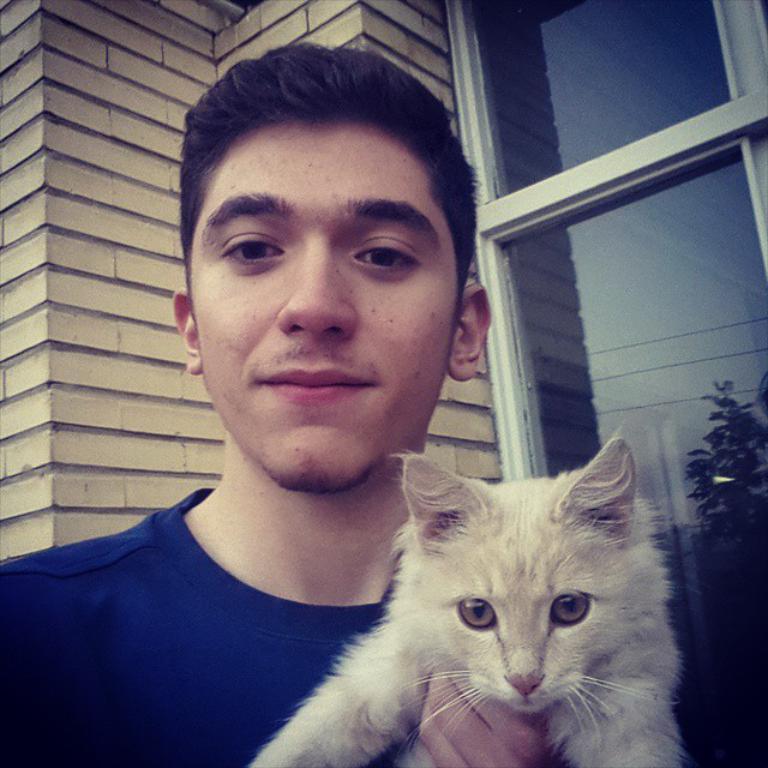Could you give a brief overview of what you see in this image? In the middle of the image a man is standing and holding a cat. Behind him there is a wall. Top right side of the image there is a glass window. 